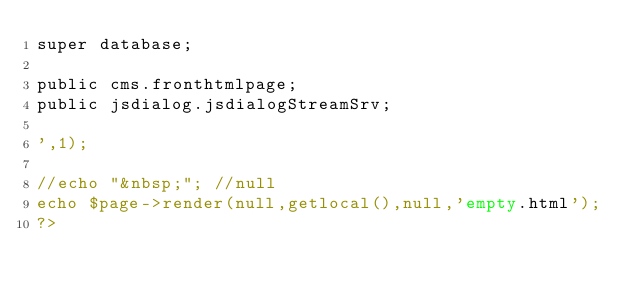Convert code to text. <code><loc_0><loc_0><loc_500><loc_500><_PHP_>super database;

public cms.fronthtmlpage;
public jsdialog.jsdialogStreamSrv;

',1);	 

//echo "&nbsp;"; //null
echo $page->render(null,getlocal(),null,'empty.html');
?>
</code> 